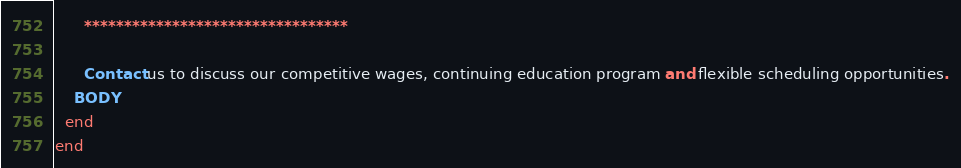<code> <loc_0><loc_0><loc_500><loc_500><_Ruby_>      *********************************

      Contact us to discuss our competitive wages, continuing education program and flexible scheduling opportunities.
    BODY
  end
end
</code> 